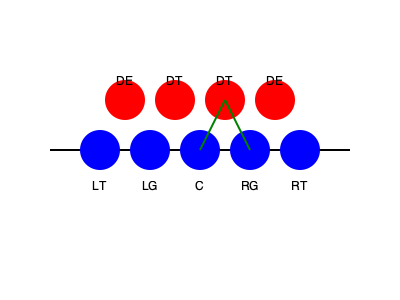Based on the illustrated blocking scheme, which gap is being targeted for a potential running play, and what type of block is being executed by the right guard (RG)? 1. Analyze the offensive line positioning:
   - The offensive line is represented by blue circles (LT, LG, C, RG, RT).
   - The defensive line is represented by red circles (DE, DT, DT, DE).

2. Identify the blocking scheme:
   - There are green lines connecting the right guard (RG) and center (C) to the defensive tackle (DT) on their right.

3. Determine the gap being targeted:
   - The gap between the center (C) and right guard (RG) is not being blocked directly.
   - This gap is known as the A-gap on the right side of the center.

4. Identify the type of block by the right guard:
   - The right guard (RG) is moving to block the defensive tackle (DT) to his right.
   - This is an example of a "down block" or "angle block."

5. Conclude the play design:
   - The blocking scheme is setting up for a run through the right A-gap.
   - The down block by the RG creates a running lane in the A-gap.
Answer: Right A-gap; Down block 